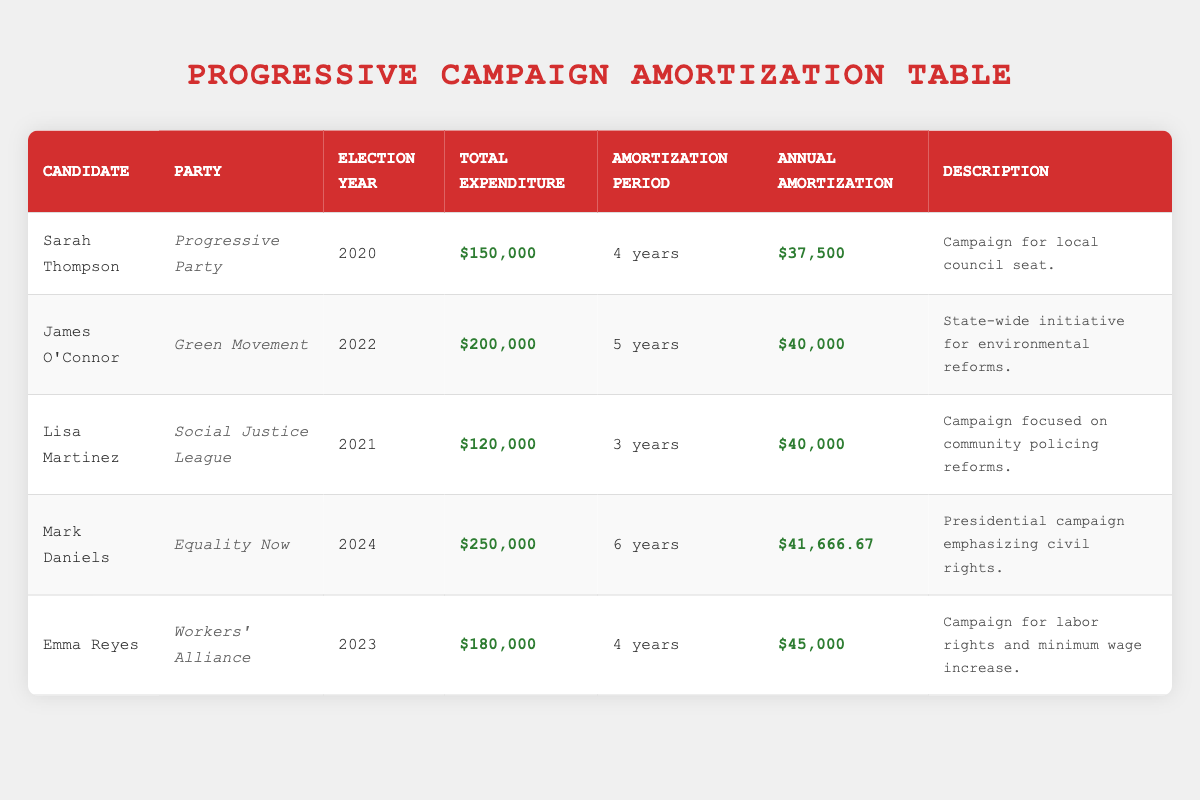What is the total expenditure for James O'Connor's campaign? James O'Connor's total expenditure is listed in the table as $200,000, which can be found in the "Total Expenditure" column for his row.
Answer: 200000 How many years is the amortization period for Sarah Thompson's campaign? Sarah Thompson's campaign has an amortization period of 4 years, as indicated in the "Amortization Period" column in her row.
Answer: 4 years Which candidate has the largest total expenditure? To find the candidate with the largest total expenditure, we can compare the "Total Expenditure" values: Sarah Thompson ($150,000), James O'Connor ($200,000), Lisa Martinez ($120,000), Mark Daniels ($250,000), and Emma Reyes ($180,000). Mark Daniels has the largest total expenditure of $250,000.
Answer: Mark Daniels What is the average annual amortization for all candidates? To calculate the average annual amortization, we add the annual amortization amounts: $37,500 (Sarah Thompson) + $40,000 (James O'Connor) + $40,000 (Lisa Martinez) + $41,666.67 (Mark Daniels) + $45,000 (Emma Reyes) = $204,166.67. Then we divide by the number of candidates (5), giving us $204,166.67 ÷ 5 = $40,833.33.
Answer: 40833.33 Is Lisa Martinez's campaign for community policing reforms smaller in total expenditure than that of Emma Reyes? Lisa Martinez's total expenditure is $120,000, while Emma Reyes's total expenditure is $180,000. Since $120,000 is less than $180,000, the statement is true.
Answer: Yes Which candidate's campaign has the shortest amortization period and what is that period? By scanning the "Amortization Period" column, we see the periods: 4 years (Sarah Thompson), 5 years (James O'Connor), 3 years (Lisa Martinez), 6 years (Mark Daniels), and 4 years (Emma Reyes). Lisa Martinez has the shortest amortization period of 3 years.
Answer: 3 years How much more does Mark Daniels spend on total expenditures compared to Sarah Thompson? Mark Daniels's total expenditure is $250,000 while Sarah Thompson's is $150,000. To find the difference, we subtract: $250,000 - $150,000 = $100,000.
Answer: 100000 Is there a candidate from the Workers' Alliance party and what was their total expenditure? Looking at the table, Emma Reyes is associated with the Workers' Alliance party, and her total expenditure is listed as $180,000. Therefore, the answer to the question is yes.
Answer: Yes Which two candidates have the same annual amortization amount? The annual amortization amounts for the candidates are: $37,500 (Sarah Thompson), $40,000 (James O'Connor), $40,000 (Lisa Martinez), $41,666.67 (Mark Daniels), and $45,000 (Emma Reyes). James O'Connor and Lisa Martinez both have the same annual amortization amount of $40,000.
Answer: James O'Connor and Lisa Martinez 